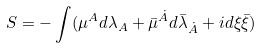<formula> <loc_0><loc_0><loc_500><loc_500>S = - \int ( \mu ^ { A } d \lambda _ { A } + \bar { \mu } ^ { \dot { A } } d \bar { \lambda } _ { \dot { A } } + i d \xi \bar { \xi } )</formula> 